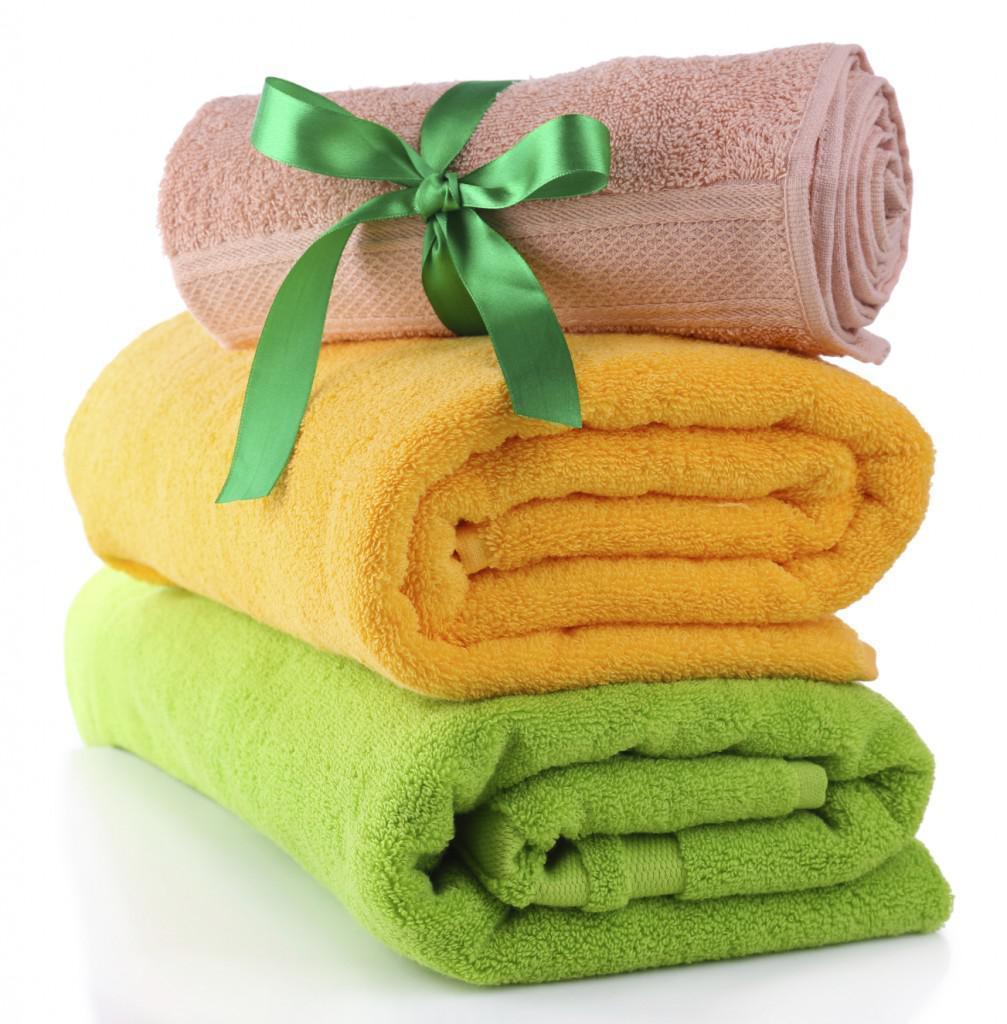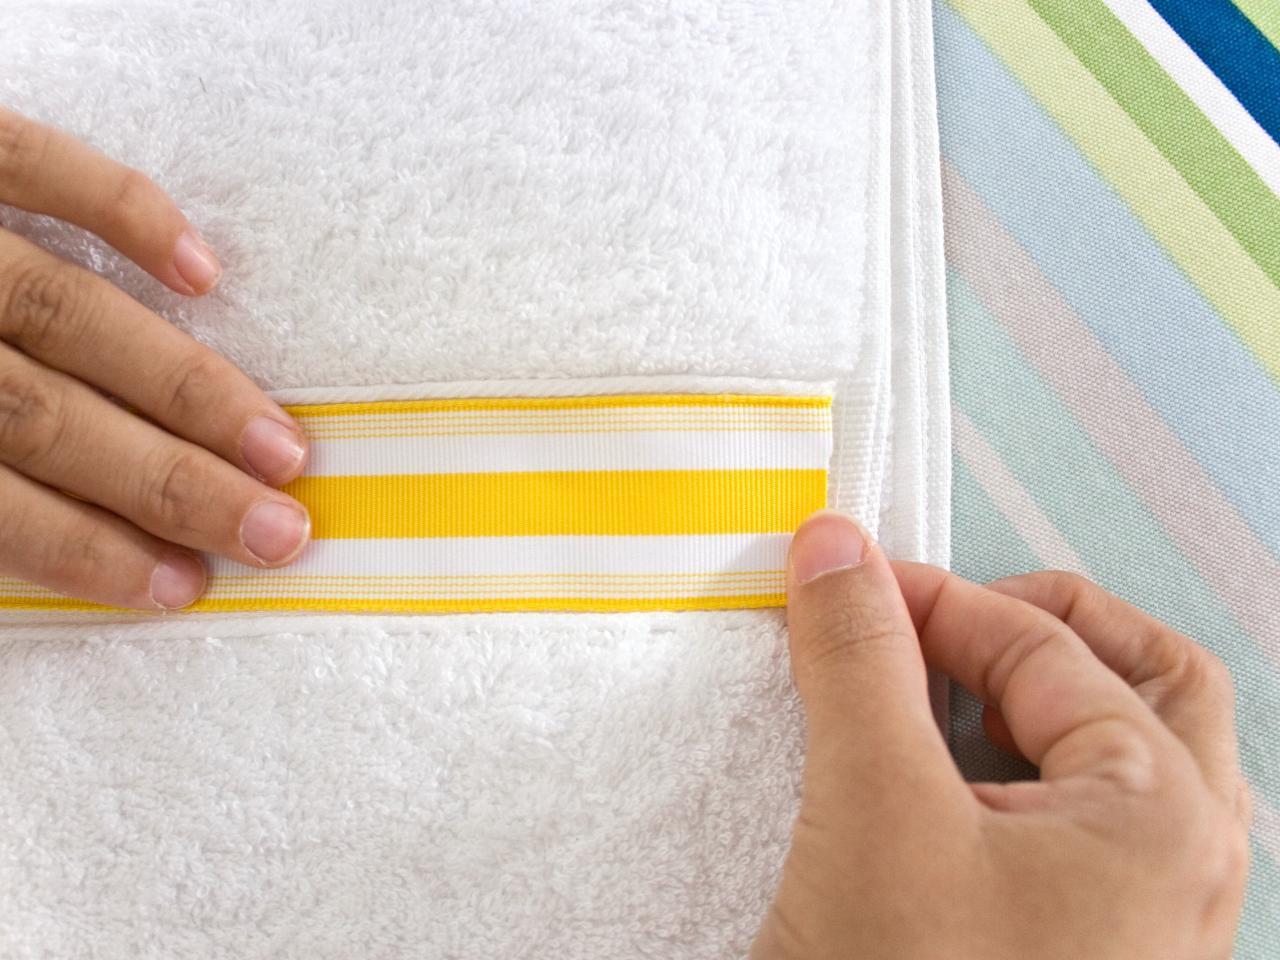The first image is the image on the left, the second image is the image on the right. Analyze the images presented: Is the assertion "There is a white towel with a yellow and white band down the center in the image on the right." valid? Answer yes or no. Yes. The first image is the image on the left, the second image is the image on the right. Analyze the images presented: Is the assertion "In the right image, there is a white towel with a white and yellow striped strip of ribbon" valid? Answer yes or no. Yes. 